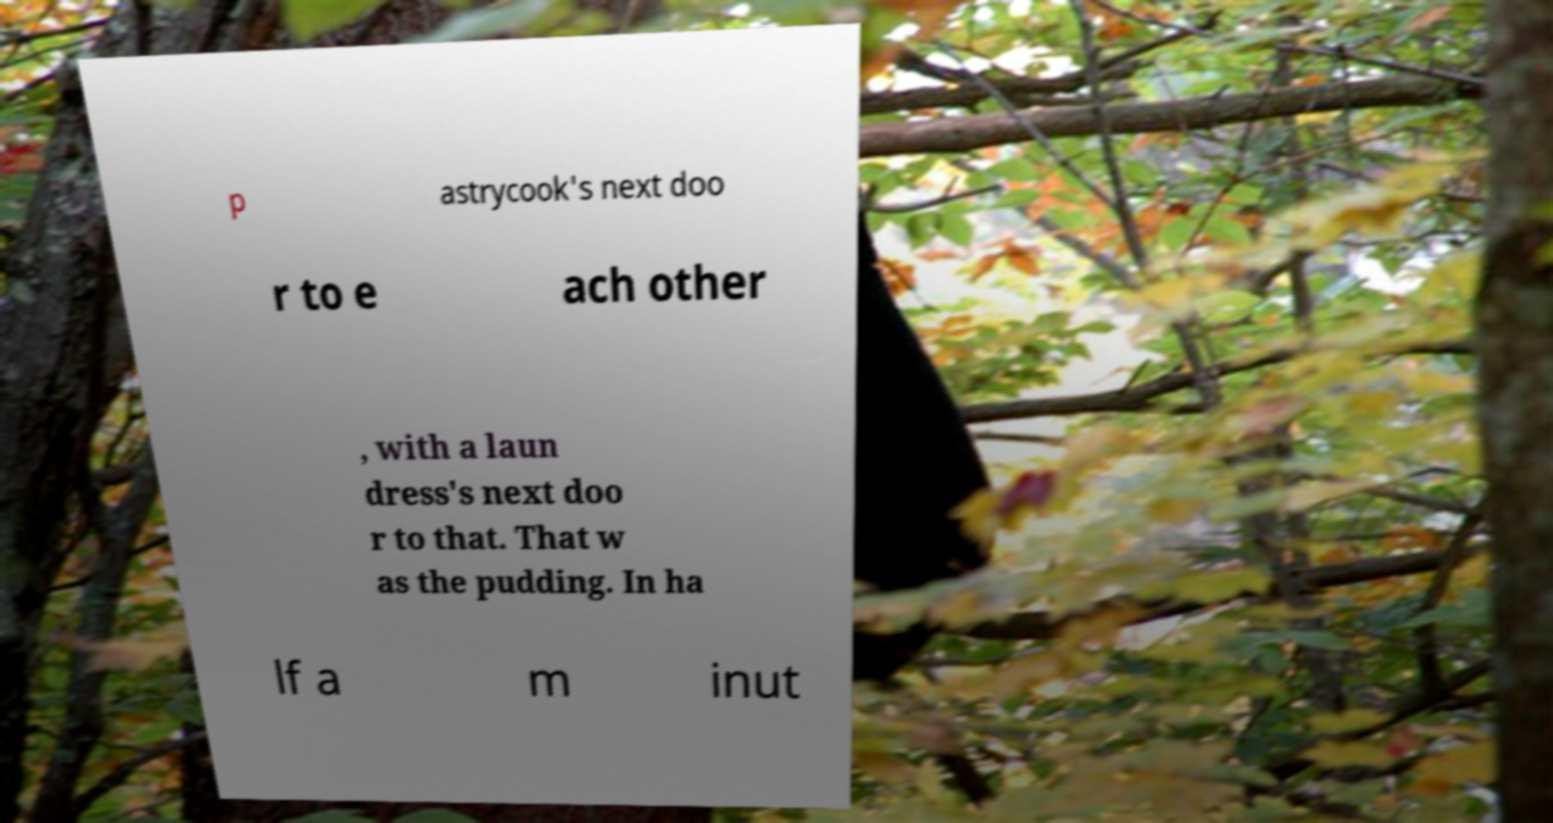Can you read and provide the text displayed in the image?This photo seems to have some interesting text. Can you extract and type it out for me? p astrycook's next doo r to e ach other , with a laun dress's next doo r to that. That w as the pudding. In ha lf a m inut 